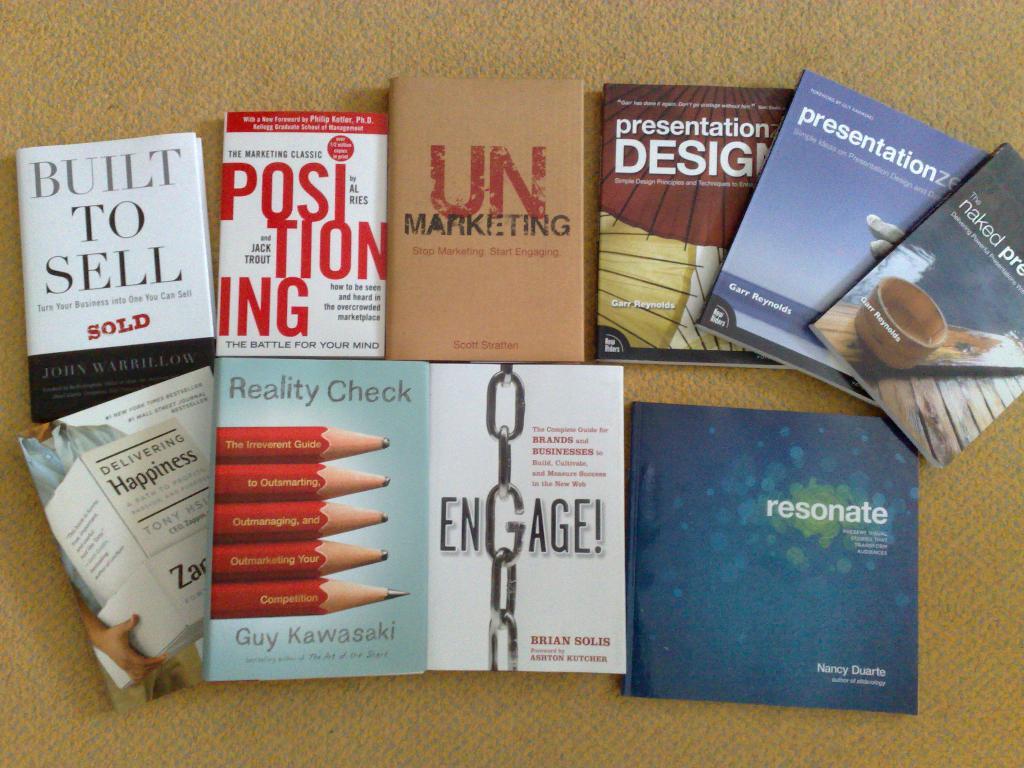Who wrote reality check?
Provide a short and direct response. Guy kawasaki. 